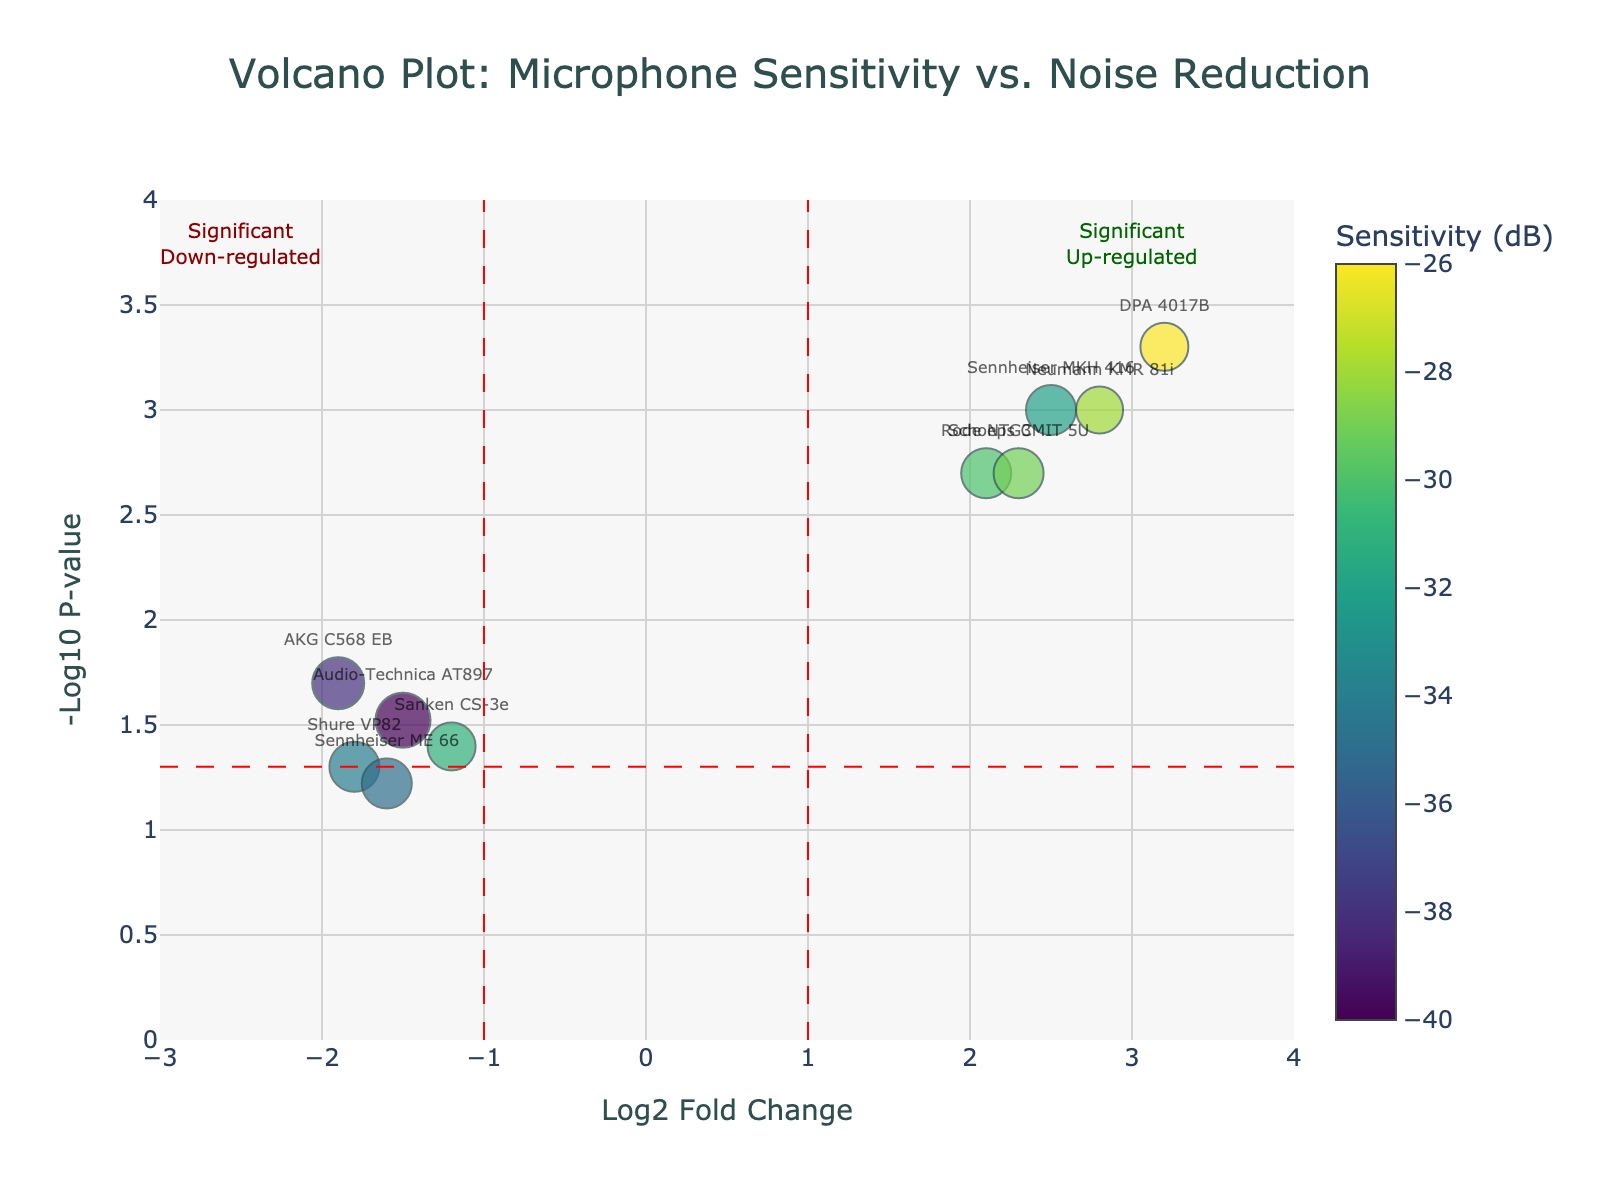What is the title of the plot? The title of the plot is displayed at the top-center of the figure, above the plot area. It is designed to provide a summary of what the plot is about.
Answer: "Volcano Plot: Microphone Sensitivity vs. Noise Reduction" How many microphone models are shown in the plot? Each microphone model is represented by a marker on the plot, and there are labels such as "Sennheiser MKH 416", "Rode NTG3", etc., indicating each model.
Answer: 10 Which microphone model has the highest sensitivity (dB)? The color bar on the right side of the plot represents sensitivity. The marker color closest to the top of the color scale represents the highest sensitivity.
Answer: DPA 4017B What does the x-axis represent? The x-axis title, located directly below the horizontal line running from left to right, explains what the x-axis measures.
Answer: Log2 Fold Change What does the y-axis represent? The y-axis title, located directly to the left of the vertical line running from bottom to top, explains what this axis measures.
Answer: -Log10 P-value Which microphone model has the most significant up-regulation? Up-regulated models are those on the right side of the plot. The significance is indicated by the highest -Log10 P-value. Looking for the marker with the highest y-value in the right half of the plot.
Answer: DPA 4017B Between the "Sennheiser MKH 416" and the "Shure VP82", which model has better noise reduction (dB)? Noise reduction is indicated by the size of the markers. By comparing the sizes of the markers for both microphone models, we can determine which one is larger.
Answer: Rode NTG3 What are the log2 fold change and -log10 p-value for the "Neumann KMR 81i"? Looking for the marker labeled "Neumann KMR 81i" positioned relative to the x and y axes, we can determine its coordinates.
Answer: 2.8 and -3.0 Do any microphones fall under the 'Significant Down-regulated' category? Markers in the "Significant Down-regulated" area are to the far left of the plot, typically below the red dashed vertical line at -1. Examining the left side of the plot reveals the markers that fall in this category.
Answer: Yes Which microphone models are outside the "Significant Down-regulated" and "Significant Up-regulated" thresholds? The thresholds are marked by red dashed lines at x-values of -1 and 1. Microphones outside these lines do not fall within significant categories.
Answer: Shure VP82, Audio-Technica AT897, Sanken CS-3e, and Sennheiser ME 66 